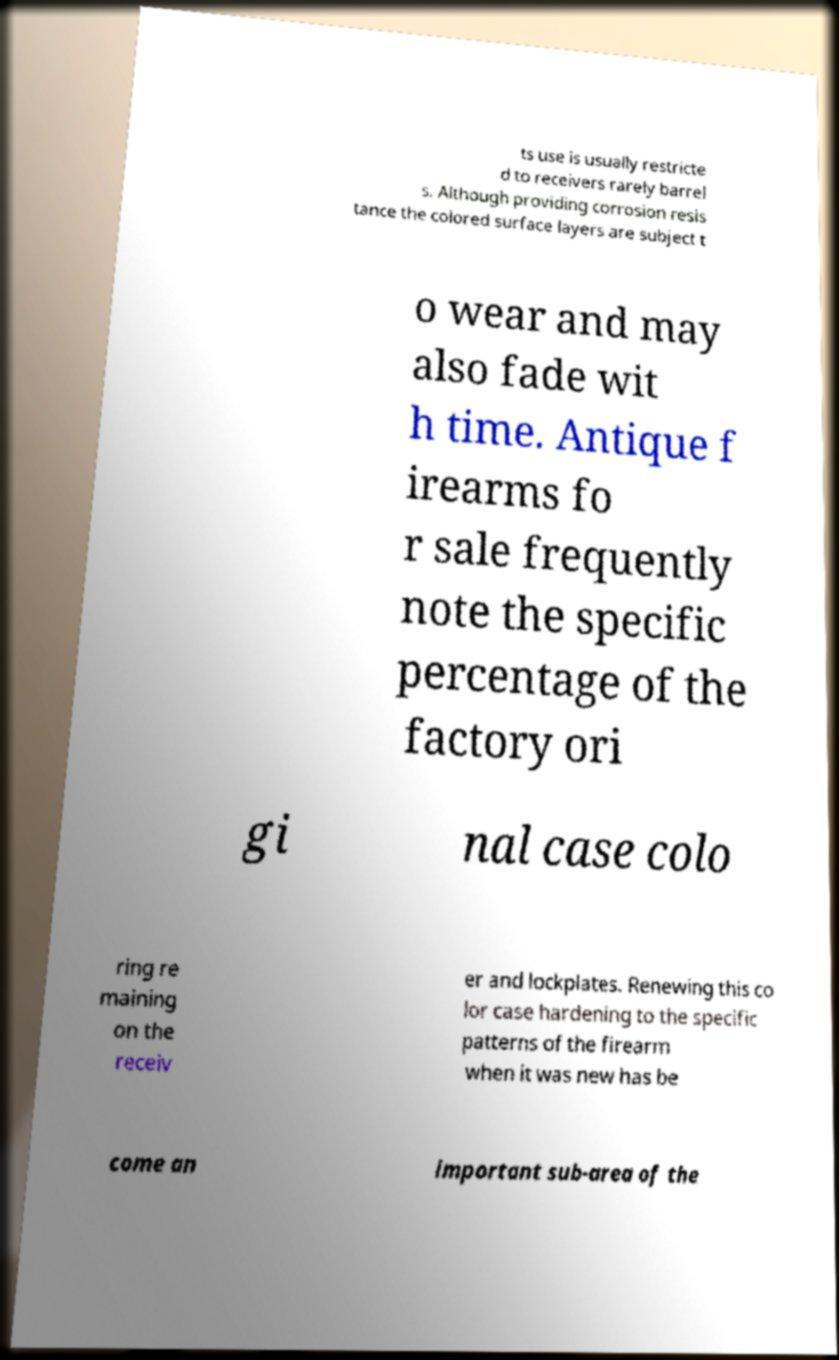Can you read and provide the text displayed in the image?This photo seems to have some interesting text. Can you extract and type it out for me? ts use is usually restricte d to receivers rarely barrel s. Although providing corrosion resis tance the colored surface layers are subject t o wear and may also fade wit h time. Antique f irearms fo r sale frequently note the specific percentage of the factory ori gi nal case colo ring re maining on the receiv er and lockplates. Renewing this co lor case hardening to the specific patterns of the firearm when it was new has be come an important sub-area of the 